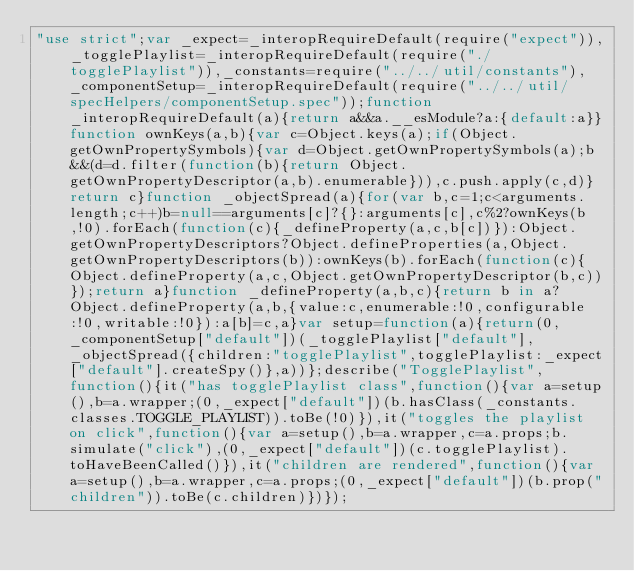<code> <loc_0><loc_0><loc_500><loc_500><_JavaScript_>"use strict";var _expect=_interopRequireDefault(require("expect")),_togglePlaylist=_interopRequireDefault(require("./togglePlaylist")),_constants=require("../../util/constants"),_componentSetup=_interopRequireDefault(require("../../util/specHelpers/componentSetup.spec"));function _interopRequireDefault(a){return a&&a.__esModule?a:{default:a}}function ownKeys(a,b){var c=Object.keys(a);if(Object.getOwnPropertySymbols){var d=Object.getOwnPropertySymbols(a);b&&(d=d.filter(function(b){return Object.getOwnPropertyDescriptor(a,b).enumerable})),c.push.apply(c,d)}return c}function _objectSpread(a){for(var b,c=1;c<arguments.length;c++)b=null==arguments[c]?{}:arguments[c],c%2?ownKeys(b,!0).forEach(function(c){_defineProperty(a,c,b[c])}):Object.getOwnPropertyDescriptors?Object.defineProperties(a,Object.getOwnPropertyDescriptors(b)):ownKeys(b).forEach(function(c){Object.defineProperty(a,c,Object.getOwnPropertyDescriptor(b,c))});return a}function _defineProperty(a,b,c){return b in a?Object.defineProperty(a,b,{value:c,enumerable:!0,configurable:!0,writable:!0}):a[b]=c,a}var setup=function(a){return(0,_componentSetup["default"])(_togglePlaylist["default"],_objectSpread({children:"togglePlaylist",togglePlaylist:_expect["default"].createSpy()},a))};describe("TogglePlaylist",function(){it("has togglePlaylist class",function(){var a=setup(),b=a.wrapper;(0,_expect["default"])(b.hasClass(_constants.classes.TOGGLE_PLAYLIST)).toBe(!0)}),it("toggles the playlist on click",function(){var a=setup(),b=a.wrapper,c=a.props;b.simulate("click"),(0,_expect["default"])(c.togglePlaylist).toHaveBeenCalled()}),it("children are rendered",function(){var a=setup(),b=a.wrapper,c=a.props;(0,_expect["default"])(b.prop("children")).toBe(c.children)})});</code> 